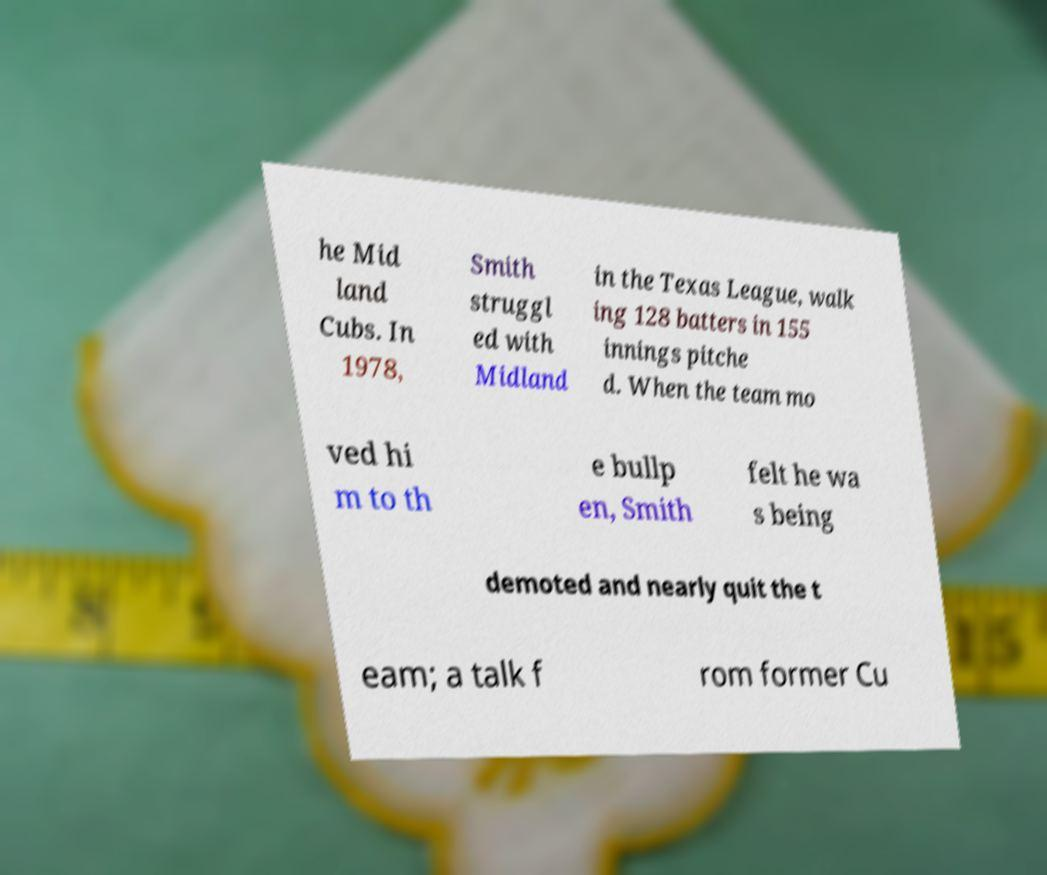Can you read and provide the text displayed in the image?This photo seems to have some interesting text. Can you extract and type it out for me? he Mid land Cubs. In 1978, Smith struggl ed with Midland in the Texas League, walk ing 128 batters in 155 innings pitche d. When the team mo ved hi m to th e bullp en, Smith felt he wa s being demoted and nearly quit the t eam; a talk f rom former Cu 